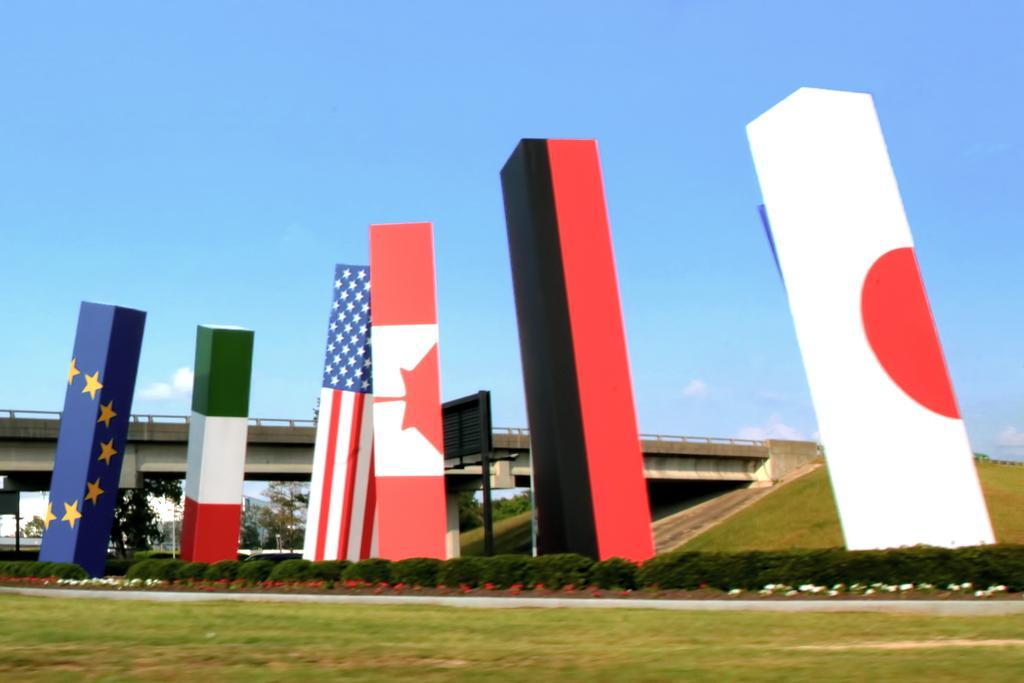Can you describe this image briefly? In this image there are boards of flags, plants with flowers, trees,grass, bridge, and in the background there is sky. 